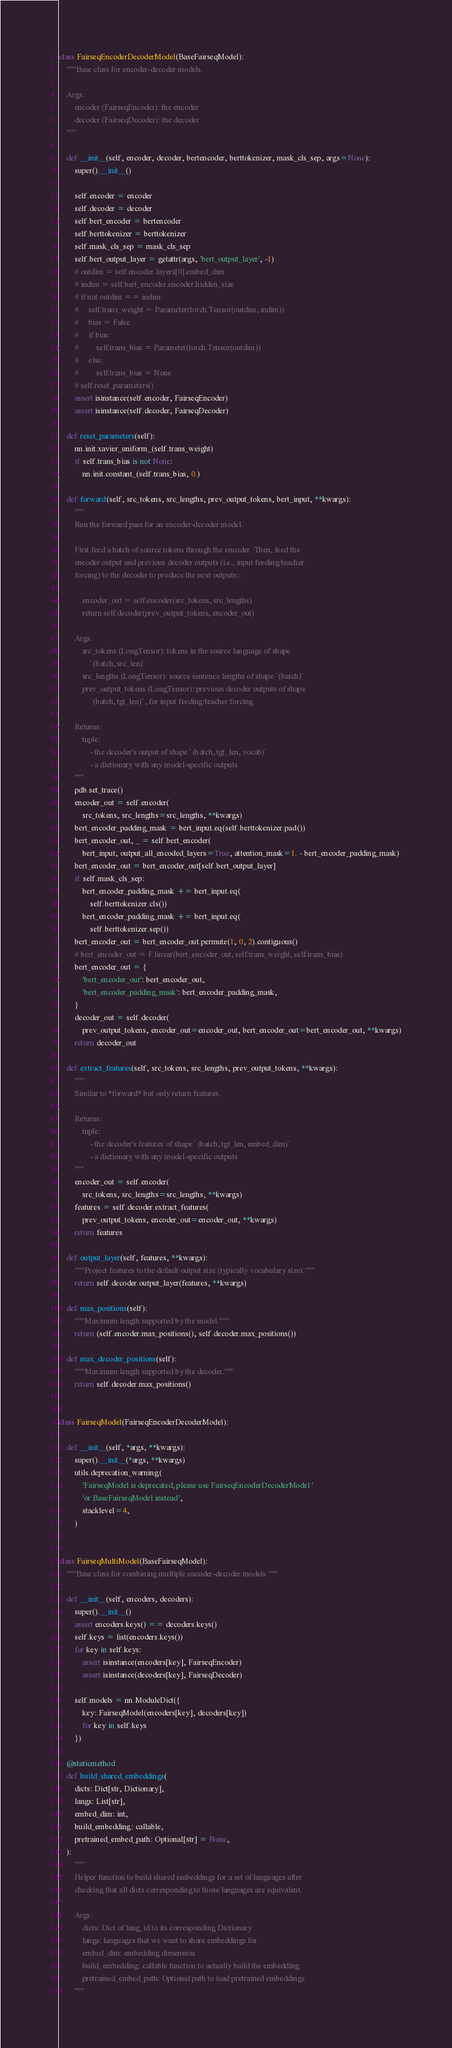Convert code to text. <code><loc_0><loc_0><loc_500><loc_500><_Python_>

class FairseqEncoderDecoderModel(BaseFairseqModel):
    """Base class for encoder-decoder models.

    Args:
        encoder (FairseqEncoder): the encoder
        decoder (FairseqDecoder): the decoder
    """

    def __init__(self, encoder, decoder, bertencoder, berttokenizer, mask_cls_sep, args=None):
        super().__init__()

        self.encoder = encoder
        self.decoder = decoder
        self.bert_encoder = bertencoder
        self.berttokenizer = berttokenizer
        self.mask_cls_sep = mask_cls_sep
        self.bert_output_layer = getattr(args, 'bert_output_layer', -1)
        # outdim = self.encoder.layers[0].embed_dim
        # indim = self.bert_encoder.encoder.hidden_size
        # if not outdim == indim:
        #     self.trans_weight = Parameter(torch.Tensor(outdim, indim))
        #     bias = False
        #     if bias:
        #         self.trans_bias = Parameter(torch.Tensor(outdim))
        #     else:
        #         self.trans_bias = None
        # self.reset_parameters()
        assert isinstance(self.encoder, FairseqEncoder)
        assert isinstance(self.decoder, FairseqDecoder)

    def reset_parameters(self):
        nn.init.xavier_uniform_(self.trans_weight)
        if self.trans_bias is not None:
            nn.init.constant_(self.trans_bias, 0.)

    def forward(self, src_tokens, src_lengths, prev_output_tokens, bert_input, **kwargs):
        """
        Run the forward pass for an encoder-decoder model.

        First feed a batch of source tokens through the encoder. Then, feed the
        encoder output and previous decoder outputs (i.e., input feeding/teacher
        forcing) to the decoder to produce the next outputs::

            encoder_out = self.encoder(src_tokens, src_lengths)
            return self.decoder(prev_output_tokens, encoder_out)

        Args:
            src_tokens (LongTensor): tokens in the source language of shape
                `(batch, src_len)`
            src_lengths (LongTensor): source sentence lengths of shape `(batch)`
            prev_output_tokens (LongTensor): previous decoder outputs of shape
                `(batch, tgt_len)`, for input feeding/teacher forcing

        Returns:
            tuple:
                - the decoder's output of shape `(batch, tgt_len, vocab)`
                - a dictionary with any model-specific outputs
        """
        pdb.set_trace()
        encoder_out = self.encoder(
            src_tokens, src_lengths=src_lengths, **kwargs)
        bert_encoder_padding_mask = bert_input.eq(self.berttokenizer.pad())
        bert_encoder_out, _ = self.bert_encoder(
            bert_input, output_all_encoded_layers=True, attention_mask=1. - bert_encoder_padding_mask)
        bert_encoder_out = bert_encoder_out[self.bert_output_layer]
        if self.mask_cls_sep:
            bert_encoder_padding_mask += bert_input.eq(
                self.berttokenizer.cls())
            bert_encoder_padding_mask += bert_input.eq(
                self.berttokenizer.sep())
        bert_encoder_out = bert_encoder_out.permute(1, 0, 2).contiguous()
        # bert_encoder_out = F.linear(bert_encoder_out, self.trans_weight, self.trans_bias)
        bert_encoder_out = {
            'bert_encoder_out': bert_encoder_out,
            'bert_encoder_padding_mask': bert_encoder_padding_mask,
        }
        decoder_out = self.decoder(
            prev_output_tokens, encoder_out=encoder_out, bert_encoder_out=bert_encoder_out, **kwargs)
        return decoder_out

    def extract_features(self, src_tokens, src_lengths, prev_output_tokens, **kwargs):
        """
        Similar to *forward* but only return features.

        Returns:
            tuple:
                - the decoder's features of shape `(batch, tgt_len, embed_dim)`
                - a dictionary with any model-specific outputs
        """
        encoder_out = self.encoder(
            src_tokens, src_lengths=src_lengths, **kwargs)
        features = self.decoder.extract_features(
            prev_output_tokens, encoder_out=encoder_out, **kwargs)
        return features

    def output_layer(self, features, **kwargs):
        """Project features to the default output size (typically vocabulary size)."""
        return self.decoder.output_layer(features, **kwargs)

    def max_positions(self):
        """Maximum length supported by the model."""
        return (self.encoder.max_positions(), self.decoder.max_positions())

    def max_decoder_positions(self):
        """Maximum length supported by the decoder."""
        return self.decoder.max_positions()


class FairseqModel(FairseqEncoderDecoderModel):

    def __init__(self, *args, **kwargs):
        super().__init__(*args, **kwargs)
        utils.deprecation_warning(
            'FairseqModel is deprecated, please use FairseqEncoderDecoderModel '
            'or BaseFairseqModel instead',
            stacklevel=4,
        )


class FairseqMultiModel(BaseFairseqModel):
    """Base class for combining multiple encoder-decoder models."""

    def __init__(self, encoders, decoders):
        super().__init__()
        assert encoders.keys() == decoders.keys()
        self.keys = list(encoders.keys())
        for key in self.keys:
            assert isinstance(encoders[key], FairseqEncoder)
            assert isinstance(decoders[key], FairseqDecoder)

        self.models = nn.ModuleDict({
            key: FairseqModel(encoders[key], decoders[key])
            for key in self.keys
        })

    @staticmethod
    def build_shared_embeddings(
        dicts: Dict[str, Dictionary],
        langs: List[str],
        embed_dim: int,
        build_embedding: callable,
        pretrained_embed_path: Optional[str] = None,
    ):
        """
        Helper function to build shared embeddings for a set of languages after
        checking that all dicts corresponding to those languages are equivalent.

        Args:
            dicts: Dict of lang_id to its corresponding Dictionary
            langs: languages that we want to share embeddings for
            embed_dim: embedding dimension
            build_embedding: callable function to actually build the embedding
            pretrained_embed_path: Optional path to load pretrained embeddings
        """</code> 